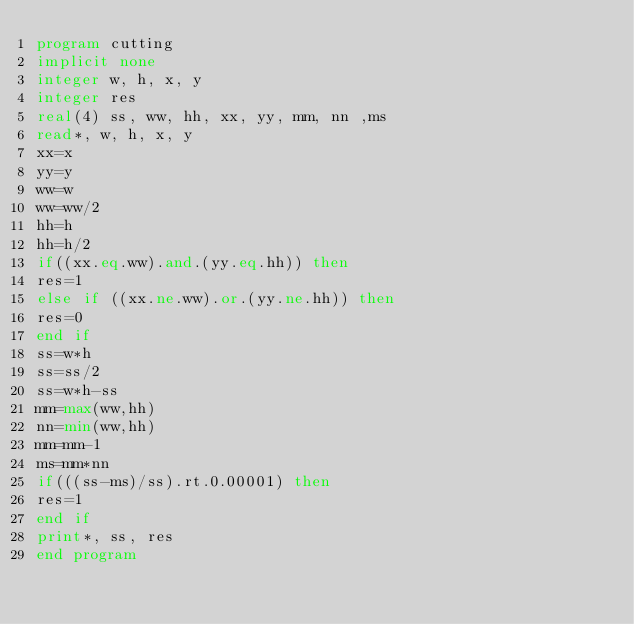<code> <loc_0><loc_0><loc_500><loc_500><_FORTRAN_>program cutting
implicit none
integer w, h, x, y
integer res
real(4) ss, ww, hh, xx, yy, mm, nn ,ms
read*, w, h, x, y
xx=x
yy=y
ww=w
ww=ww/2
hh=h
hh=h/2
if((xx.eq.ww).and.(yy.eq.hh)) then 
res=1
else if ((xx.ne.ww).or.(yy.ne.hh)) then
res=0
end if
ss=w*h
ss=ss/2
ss=w*h-ss
mm=max(ww,hh)
nn=min(ww,hh)
mm=mm-1
ms=mm*nn
if(((ss-ms)/ss).rt.0.00001) then
res=1
end if
print*, ss, res
end program</code> 